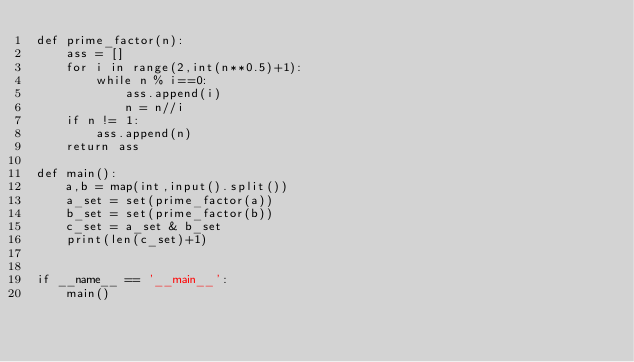Convert code to text. <code><loc_0><loc_0><loc_500><loc_500><_Python_>def prime_factor(n):
    ass = []
    for i in range(2,int(n**0.5)+1):
        while n % i==0:
            ass.append(i)
            n = n//i
    if n != 1:
        ass.append(n)
    return ass

def main():
    a,b = map(int,input().split())
    a_set = set(prime_factor(a))
    b_set = set(prime_factor(b))
    c_set = a_set & b_set
    print(len(c_set)+1)


if __name__ == '__main__':
    main()
</code> 